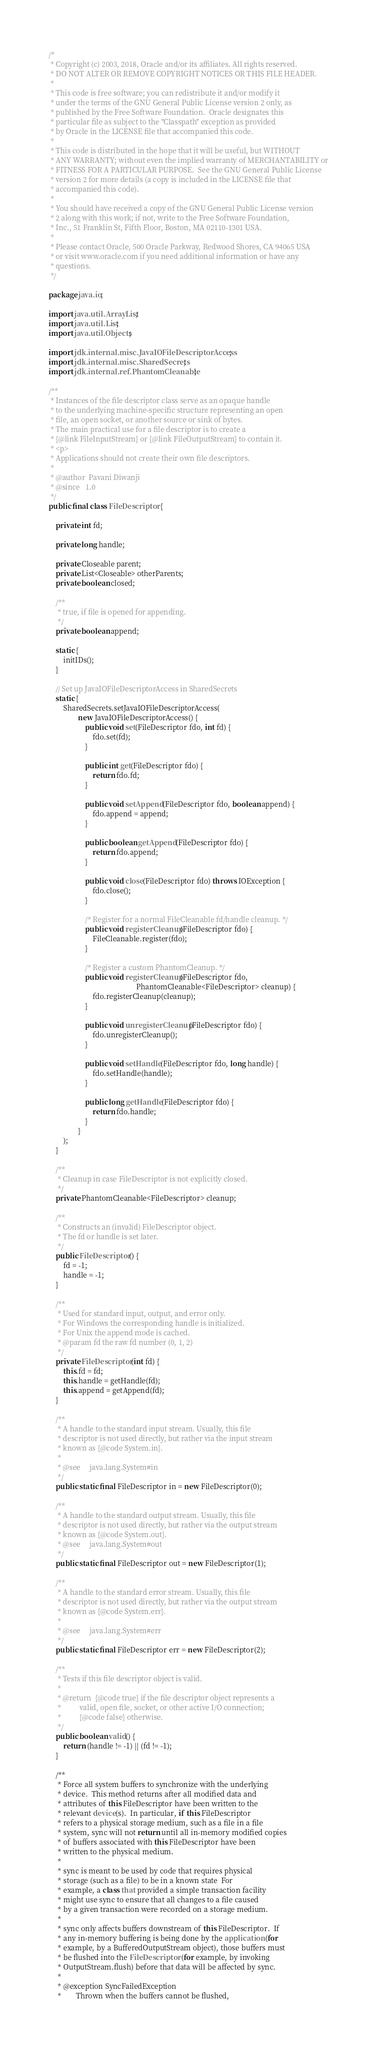<code> <loc_0><loc_0><loc_500><loc_500><_Java_>/*
 * Copyright (c) 2003, 2018, Oracle and/or its affiliates. All rights reserved.
 * DO NOT ALTER OR REMOVE COPYRIGHT NOTICES OR THIS FILE HEADER.
 *
 * This code is free software; you can redistribute it and/or modify it
 * under the terms of the GNU General Public License version 2 only, as
 * published by the Free Software Foundation.  Oracle designates this
 * particular file as subject to the "Classpath" exception as provided
 * by Oracle in the LICENSE file that accompanied this code.
 *
 * This code is distributed in the hope that it will be useful, but WITHOUT
 * ANY WARRANTY; without even the implied warranty of MERCHANTABILITY or
 * FITNESS FOR A PARTICULAR PURPOSE.  See the GNU General Public License
 * version 2 for more details (a copy is included in the LICENSE file that
 * accompanied this code).
 *
 * You should have received a copy of the GNU General Public License version
 * 2 along with this work; if not, write to the Free Software Foundation,
 * Inc., 51 Franklin St, Fifth Floor, Boston, MA 02110-1301 USA.
 *
 * Please contact Oracle, 500 Oracle Parkway, Redwood Shores, CA 94065 USA
 * or visit www.oracle.com if you need additional information or have any
 * questions.
 */

package java.io;

import java.util.ArrayList;
import java.util.List;
import java.util.Objects;

import jdk.internal.misc.JavaIOFileDescriptorAccess;
import jdk.internal.misc.SharedSecrets;
import jdk.internal.ref.PhantomCleanable;

/**
 * Instances of the file descriptor class serve as an opaque handle
 * to the underlying machine-specific structure representing an open
 * file, an open socket, or another source or sink of bytes.
 * The main practical use for a file descriptor is to create a
 * {@link FileInputStream} or {@link FileOutputStream} to contain it.
 * <p>
 * Applications should not create their own file descriptors.
 *
 * @author  Pavani Diwanji
 * @since   1.0
 */
public final class FileDescriptor {

    private int fd;

    private long handle;

    private Closeable parent;
    private List<Closeable> otherParents;
    private boolean closed;

    /**
     * true, if file is opened for appending.
     */
    private boolean append;

    static {
        initIDs();
    }

    // Set up JavaIOFileDescriptorAccess in SharedSecrets
    static {
        SharedSecrets.setJavaIOFileDescriptorAccess(
                new JavaIOFileDescriptorAccess() {
                    public void set(FileDescriptor fdo, int fd) {
                        fdo.set(fd);
                    }

                    public int get(FileDescriptor fdo) {
                        return fdo.fd;
                    }

                    public void setAppend(FileDescriptor fdo, boolean append) {
                        fdo.append = append;
                    }

                    public boolean getAppend(FileDescriptor fdo) {
                        return fdo.append;
                    }

                    public void close(FileDescriptor fdo) throws IOException {
                        fdo.close();
                    }

                    /* Register for a normal FileCleanable fd/handle cleanup. */
                    public void registerCleanup(FileDescriptor fdo) {
                        FileCleanable.register(fdo);
                    }

                    /* Register a custom PhantomCleanup. */
                    public void registerCleanup(FileDescriptor fdo,
                                                PhantomCleanable<FileDescriptor> cleanup) {
                        fdo.registerCleanup(cleanup);
                    }

                    public void unregisterCleanup(FileDescriptor fdo) {
                        fdo.unregisterCleanup();
                    }

                    public void setHandle(FileDescriptor fdo, long handle) {
                        fdo.setHandle(handle);
                    }

                    public long getHandle(FileDescriptor fdo) {
                        return fdo.handle;
                    }
                }
        );
    }

    /**
     * Cleanup in case FileDescriptor is not explicitly closed.
     */
    private PhantomCleanable<FileDescriptor> cleanup;

    /**
     * Constructs an (invalid) FileDescriptor object.
     * The fd or handle is set later.
     */
    public FileDescriptor() {
        fd = -1;
        handle = -1;
    }

    /**
     * Used for standard input, output, and error only.
     * For Windows the corresponding handle is initialized.
     * For Unix the append mode is cached.
     * @param fd the raw fd number (0, 1, 2)
     */
    private FileDescriptor(int fd) {
        this.fd = fd;
        this.handle = getHandle(fd);
        this.append = getAppend(fd);
    }

    /**
     * A handle to the standard input stream. Usually, this file
     * descriptor is not used directly, but rather via the input stream
     * known as {@code System.in}.
     *
     * @see     java.lang.System#in
     */
    public static final FileDescriptor in = new FileDescriptor(0);

    /**
     * A handle to the standard output stream. Usually, this file
     * descriptor is not used directly, but rather via the output stream
     * known as {@code System.out}.
     * @see     java.lang.System#out
     */
    public static final FileDescriptor out = new FileDescriptor(1);

    /**
     * A handle to the standard error stream. Usually, this file
     * descriptor is not used directly, but rather via the output stream
     * known as {@code System.err}.
     *
     * @see     java.lang.System#err
     */
    public static final FileDescriptor err = new FileDescriptor(2);

    /**
     * Tests if this file descriptor object is valid.
     *
     * @return  {@code true} if the file descriptor object represents a
     *          valid, open file, socket, or other active I/O connection;
     *          {@code false} otherwise.
     */
    public boolean valid() {
        return (handle != -1) || (fd != -1);
    }

    /**
     * Force all system buffers to synchronize with the underlying
     * device.  This method returns after all modified data and
     * attributes of this FileDescriptor have been written to the
     * relevant device(s).  In particular, if this FileDescriptor
     * refers to a physical storage medium, such as a file in a file
     * system, sync will not return until all in-memory modified copies
     * of buffers associated with this FileDescriptor have been
     * written to the physical medium.
     *
     * sync is meant to be used by code that requires physical
     * storage (such as a file) to be in a known state  For
     * example, a class that provided a simple transaction facility
     * might use sync to ensure that all changes to a file caused
     * by a given transaction were recorded on a storage medium.
     *
     * sync only affects buffers downstream of this FileDescriptor.  If
     * any in-memory buffering is being done by the application (for
     * example, by a BufferedOutputStream object), those buffers must
     * be flushed into the FileDescriptor (for example, by invoking
     * OutputStream.flush) before that data will be affected by sync.
     *
     * @exception SyncFailedException
     *        Thrown when the buffers cannot be flushed,</code> 